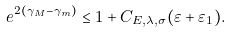Convert formula to latex. <formula><loc_0><loc_0><loc_500><loc_500>e ^ { 2 ( \gamma _ { M } - \gamma _ { m } ) } \leq 1 + C _ { E , \lambda , \sigma } ( \varepsilon + \varepsilon _ { 1 } ) .</formula> 